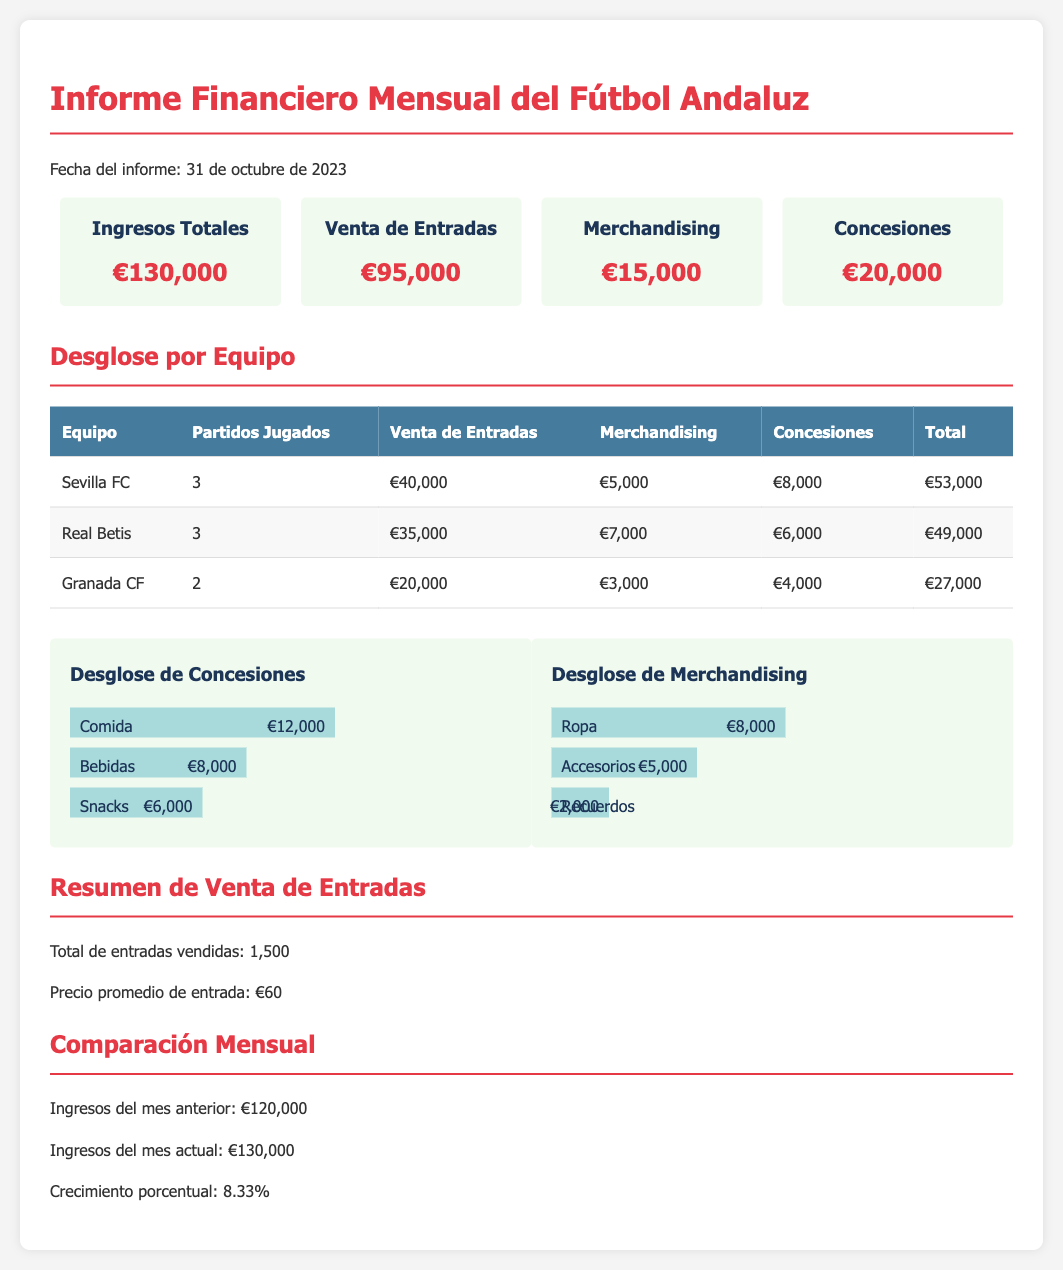¿Cuáles son los ingresos totales? Los ingresos totales se indican en la sección de resumen del informe como €130,000.
Answer: €130,000 ¿Cuánto se recaudó por la venta de entradas? La venta de entradas se detalla en la sección de resumen del informe como €95,000.
Answer: €95,000 ¿Qué equipo generó más ingresos totales? En el desglose por equipo, Sevilla FC muestra el mayor ingreso total de €53,000.
Answer: Sevilla FC ¿Cuántos partidos jugó Granada CF? La tabla del desglose por equipo muestra que Granada CF jugó 2 partidos.
Answer: 2 ¿Cuál fue el crecimiento porcentual de los ingresos respecto al mes anterior? La comparación mensual indica que el crecimiento porcentual de los ingresos fue del 8.33%.
Answer: 8.33% ¿Cuál es el total recaudado por concesiones? En el desglose por ingresos, las concesiones suman un total de €20,000.
Answer: €20,000 ¿Cuánto se vendió en merchandising? La sección de resumen indica que el ingreso por merchandising fue de €15,000.
Answer: €15,000 ¿Cuál es el precio promedio de la entrada? En el resumen de venta de entradas se menciona que el precio promedio es de €60.
Answer: €60 